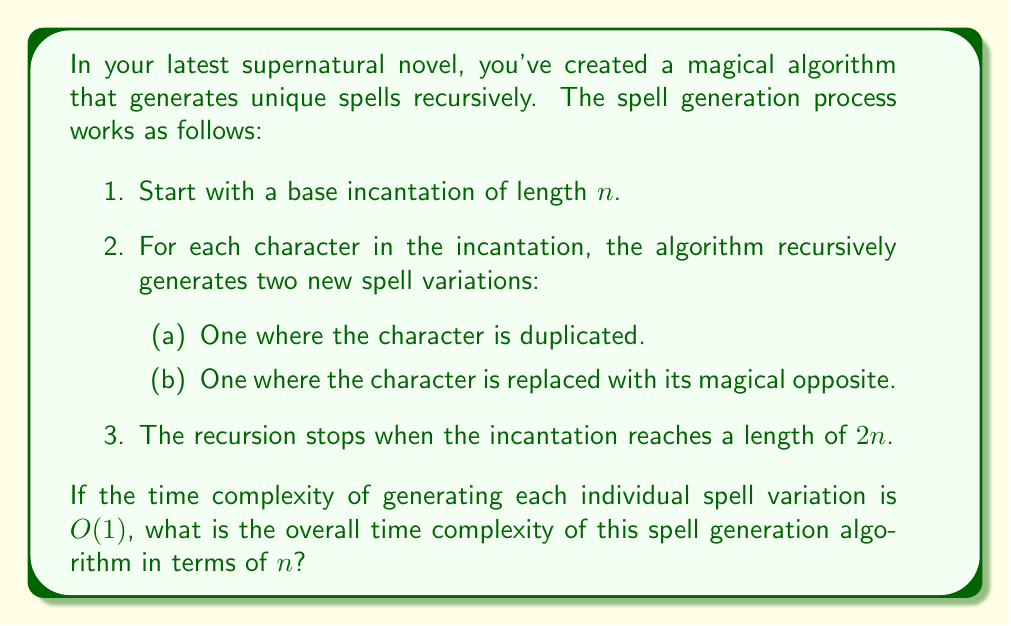Can you answer this question? Let's approach this step-by-step:

1) First, we need to understand the structure of the recursion. For each character in the original incantation, we're generating two new spells, and this process continues until the length doubles.

2) Let's denote the number of spells generated for an incantation of length $k$ as $T(k)$. We can write a recurrence relation:

   $T(k) = 2k \cdot T(k+1)$ for $n \leq k < 2n$
   $T(2n) = 1$

3) This is because for each of the $k$ characters, we're generating 2 new spells of length $k+1$.

4) To solve this, let's work backwards from $T(2n)$:

   $T(2n-1) = 2(2n-1) \cdot 1 = 4n-2$
   $T(2n-2) = 2(2n-2) \cdot (4n-2) = (4n-4)(4n-2)$
   $T(2n-3) = 2(2n-3) \cdot (4n-4)(4n-2)$
   ...

5) We can see a pattern forming. The general term would be:

   $T(k) = 2^{2n-k} \cdot (2n-k)! \cdot (4n-2)!!$ for $n \leq k \leq 2n$

   Where $(4n-2)!!$ is the double factorial of $4n-2$.

6) We're interested in $T(n)$, which is:

   $T(n) = 2^n \cdot n! \cdot (4n-2)!!$

7) This is clearly exponential in $n$. To be more precise, we can use Stirling's approximation for the factorials:

   $n! \approx \sqrt{2\pi n} (\frac{n}{e})^n$

8) Applying this, we get:

   $T(n) \in O(2^n \cdot n^n \cdot (2n)^{2n})$

9) This simplifies to:

   $T(n) \in O((4n)^{2n})$

Therefore, the time complexity is $O((4n)^{2n})$.
Answer: $O((4n)^{2n})$ 